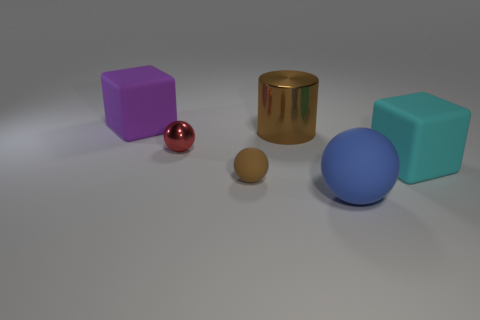What can you infer about the lighting in the image? The image has a diffused lighting setup with potential soft light sources, as indicated by the subtle shadows and gentle highlights on the objects. The absence of sharp, dark shadows suggests ambient light is uniformly spread across the scene. 